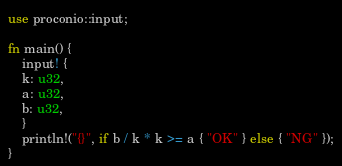<code> <loc_0><loc_0><loc_500><loc_500><_Rust_>use proconio::input;

fn main() {
    input! {
	k: u32,
	a: u32,
	b: u32,
    }
    println!("{}", if b / k * k >= a { "OK" } else { "NG" });
}

</code> 